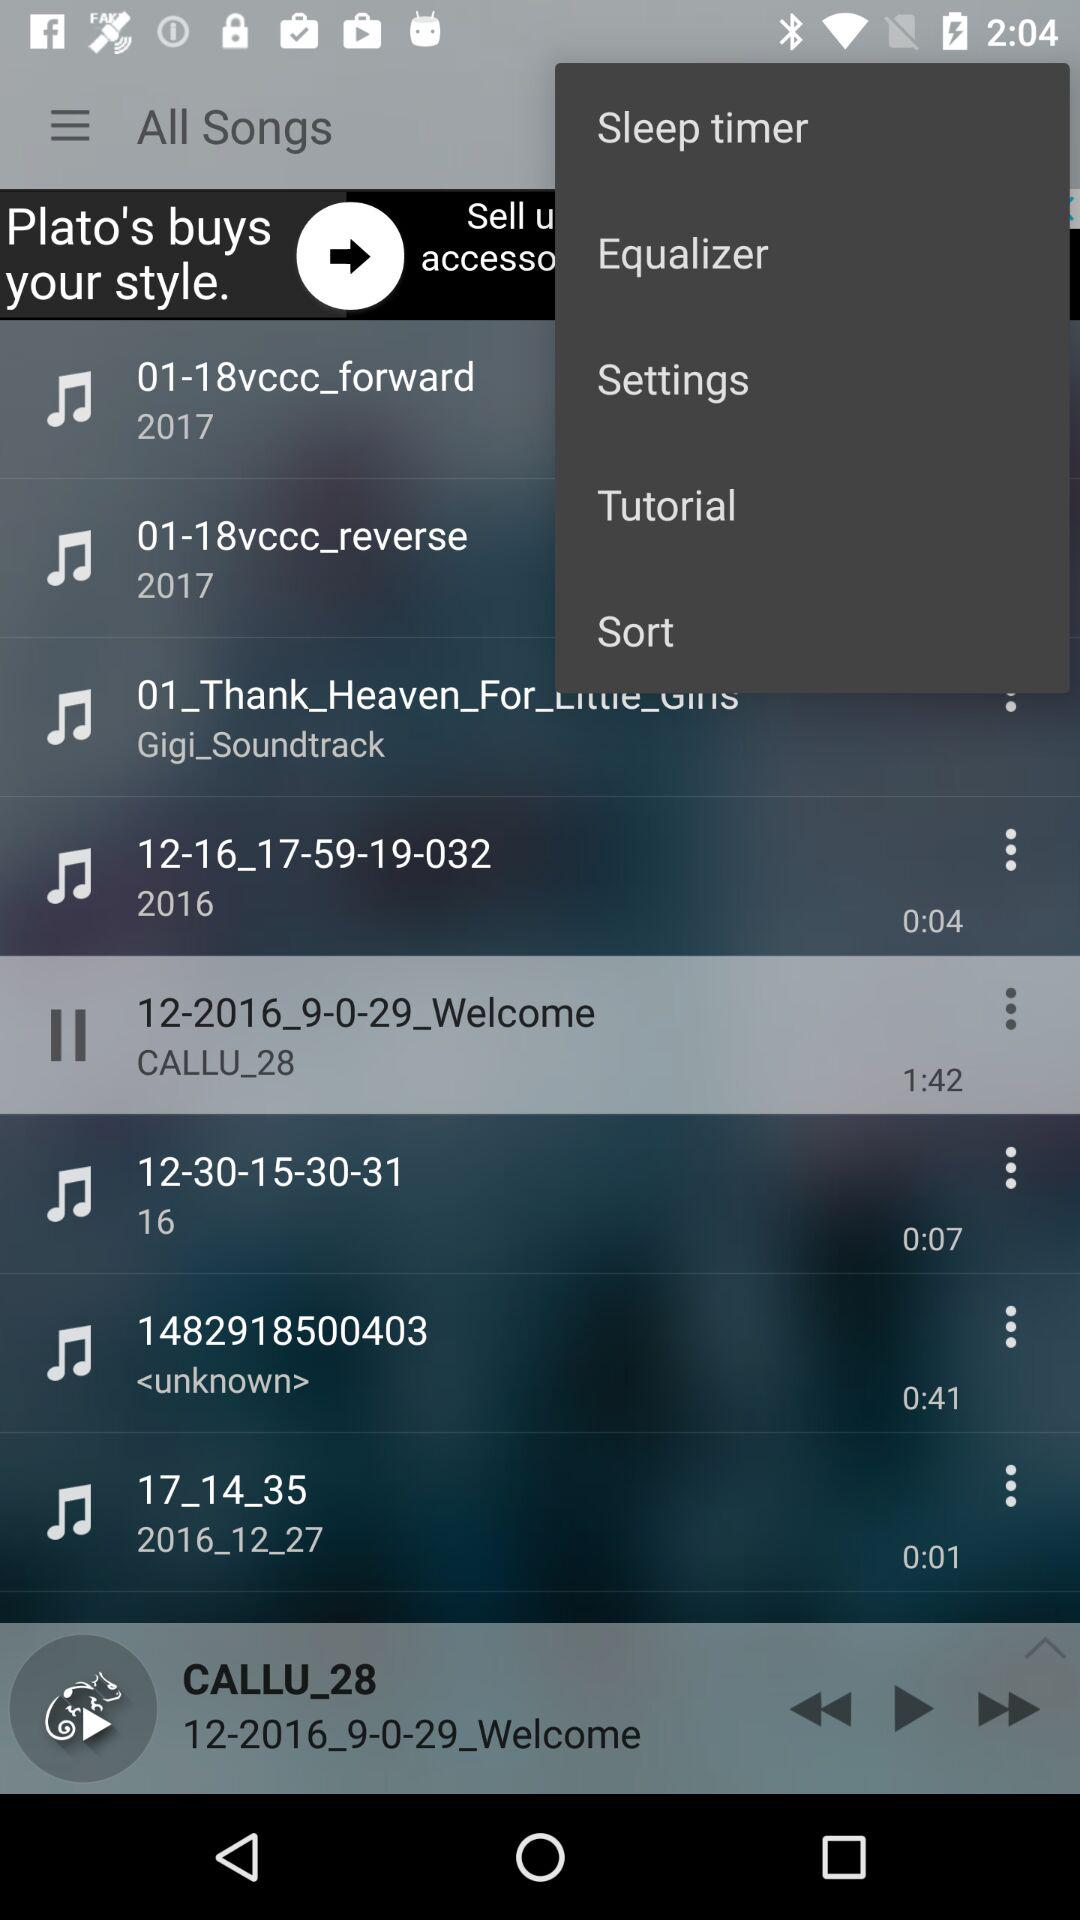What is the time duration of the song 1482918500403? The duration is 41 seconds. 